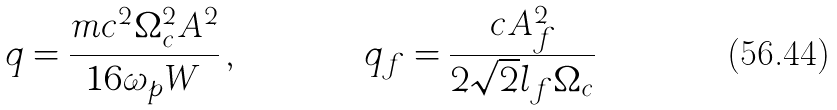Convert formula to latex. <formula><loc_0><loc_0><loc_500><loc_500>q & = \frac { m c ^ { 2 } \Omega _ { c } ^ { 2 } A ^ { 2 } } { 1 6 \omega _ { p } W } \, , & q _ { f } & = \frac { c A _ { f } ^ { 2 } } { 2 \sqrt { 2 } l _ { f } \Omega _ { c } }</formula> 